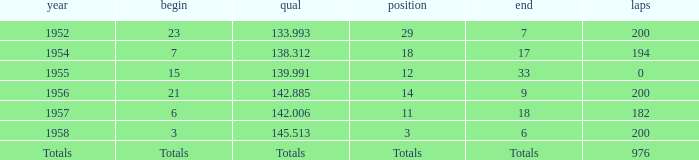Could you help me parse every detail presented in this table? {'header': ['year', 'begin', 'qual', 'position', 'end', 'laps'], 'rows': [['1952', '23', '133.993', '29', '7', '200'], ['1954', '7', '138.312', '18', '17', '194'], ['1955', '15', '139.991', '12', '33', '0'], ['1956', '21', '142.885', '14', '9', '200'], ['1957', '6', '142.006', '11', '18', '182'], ['1958', '3', '145.513', '3', '6', '200'], ['Totals', 'Totals', 'Totals', 'Totals', 'Totals', '976']]} What place did Jimmy Reece start from when he ranked 12? 15.0. 